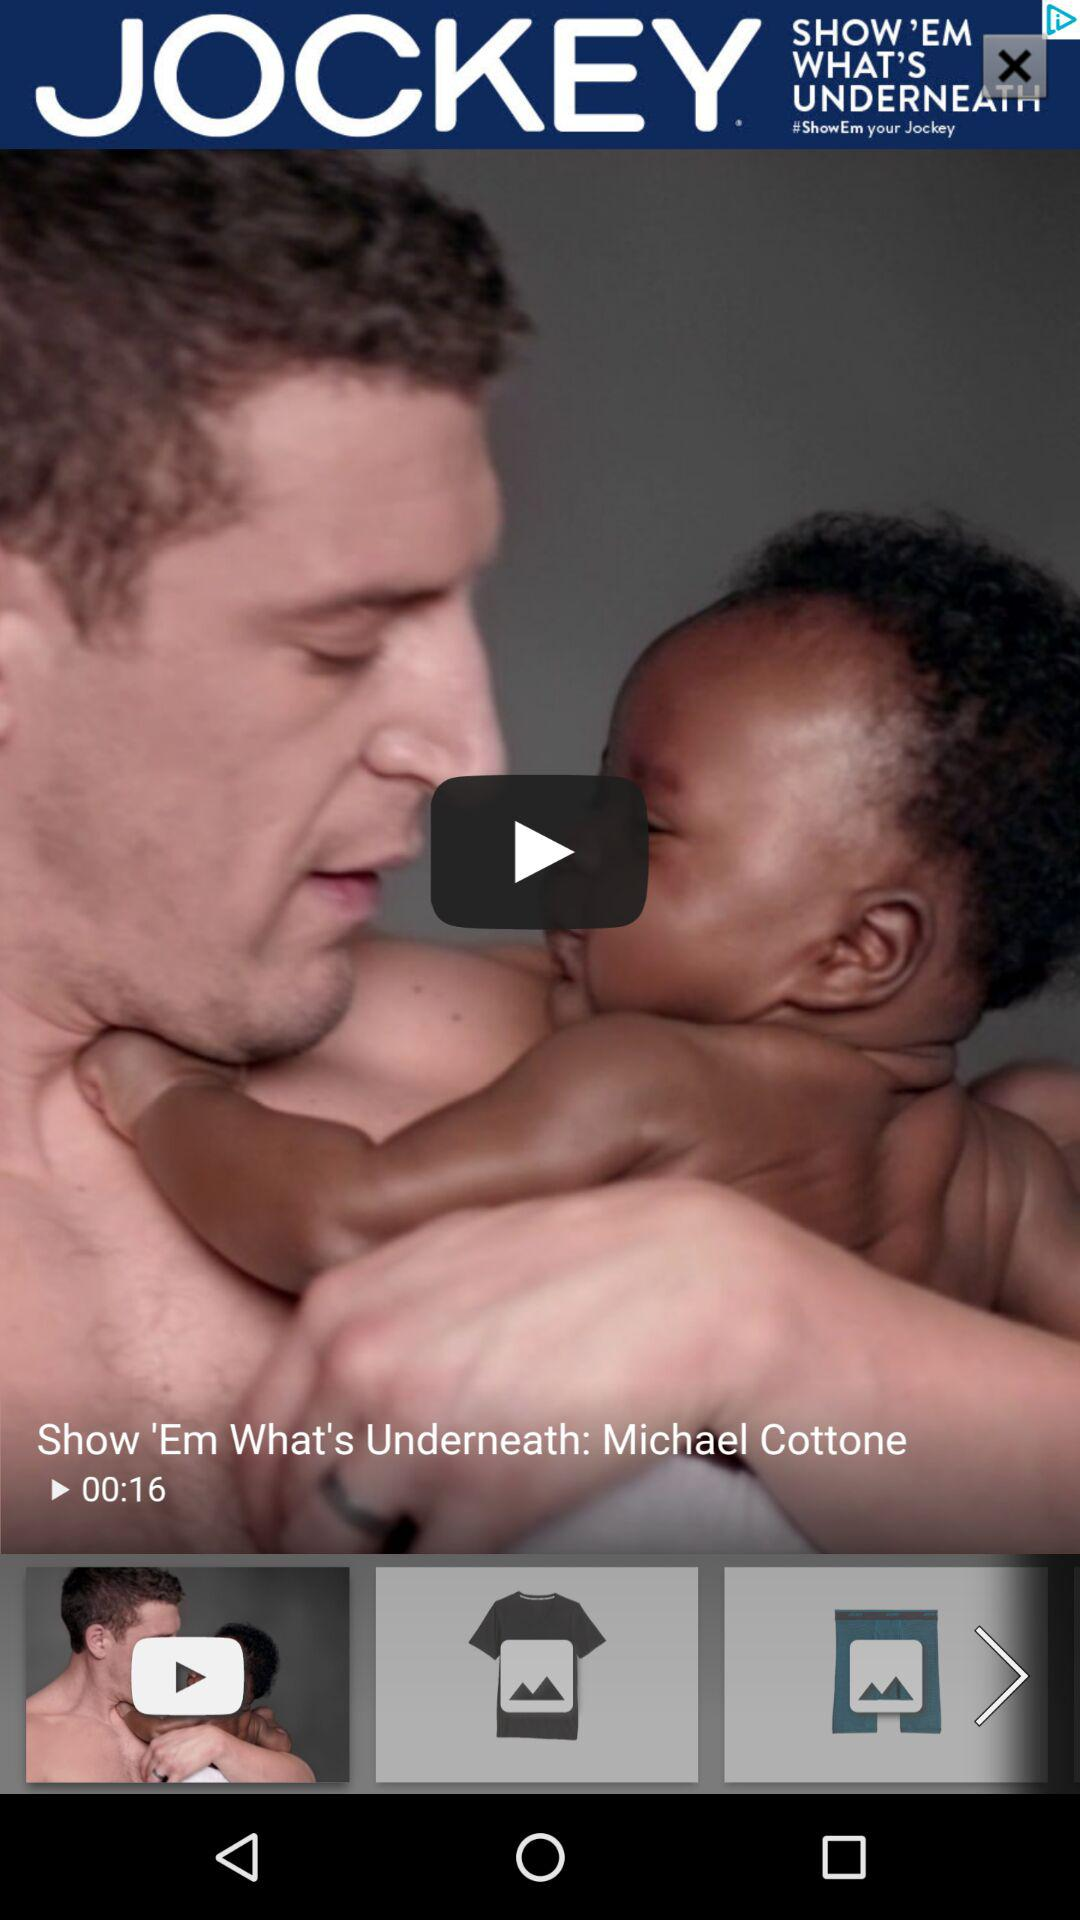What is the duration of the video? The duration of the video is 16 seconds. 